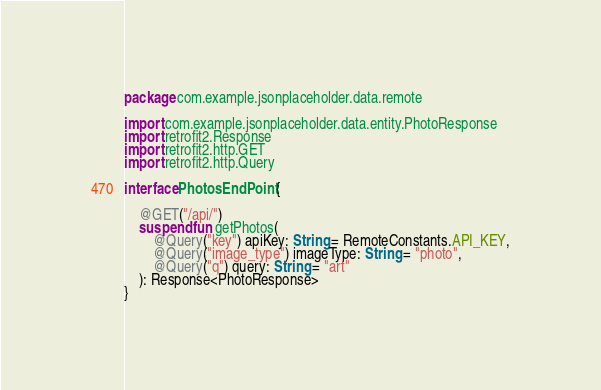Convert code to text. <code><loc_0><loc_0><loc_500><loc_500><_Kotlin_>package com.example.jsonplaceholder.data.remote

import com.example.jsonplaceholder.data.entity.PhotoResponse
import retrofit2.Response
import retrofit2.http.GET
import retrofit2.http.Query

interface PhotosEndPoint {

    @GET("/api/")
    suspend fun getPhotos(
        @Query("key") apiKey: String = RemoteConstants.API_KEY,
        @Query("image_type") imageType: String = "photo",
        @Query("q") query: String = "art"
    ): Response<PhotoResponse>
}</code> 